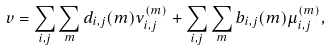<formula> <loc_0><loc_0><loc_500><loc_500>v = \sum _ { i , j } \sum _ { m } d _ { i , j } ( m ) \nu _ { i , j } ^ { ( m ) } + \sum _ { i , j } \sum _ { m } b _ { i , j } ( m ) \mu _ { i , j } ^ { ( m ) } ,</formula> 